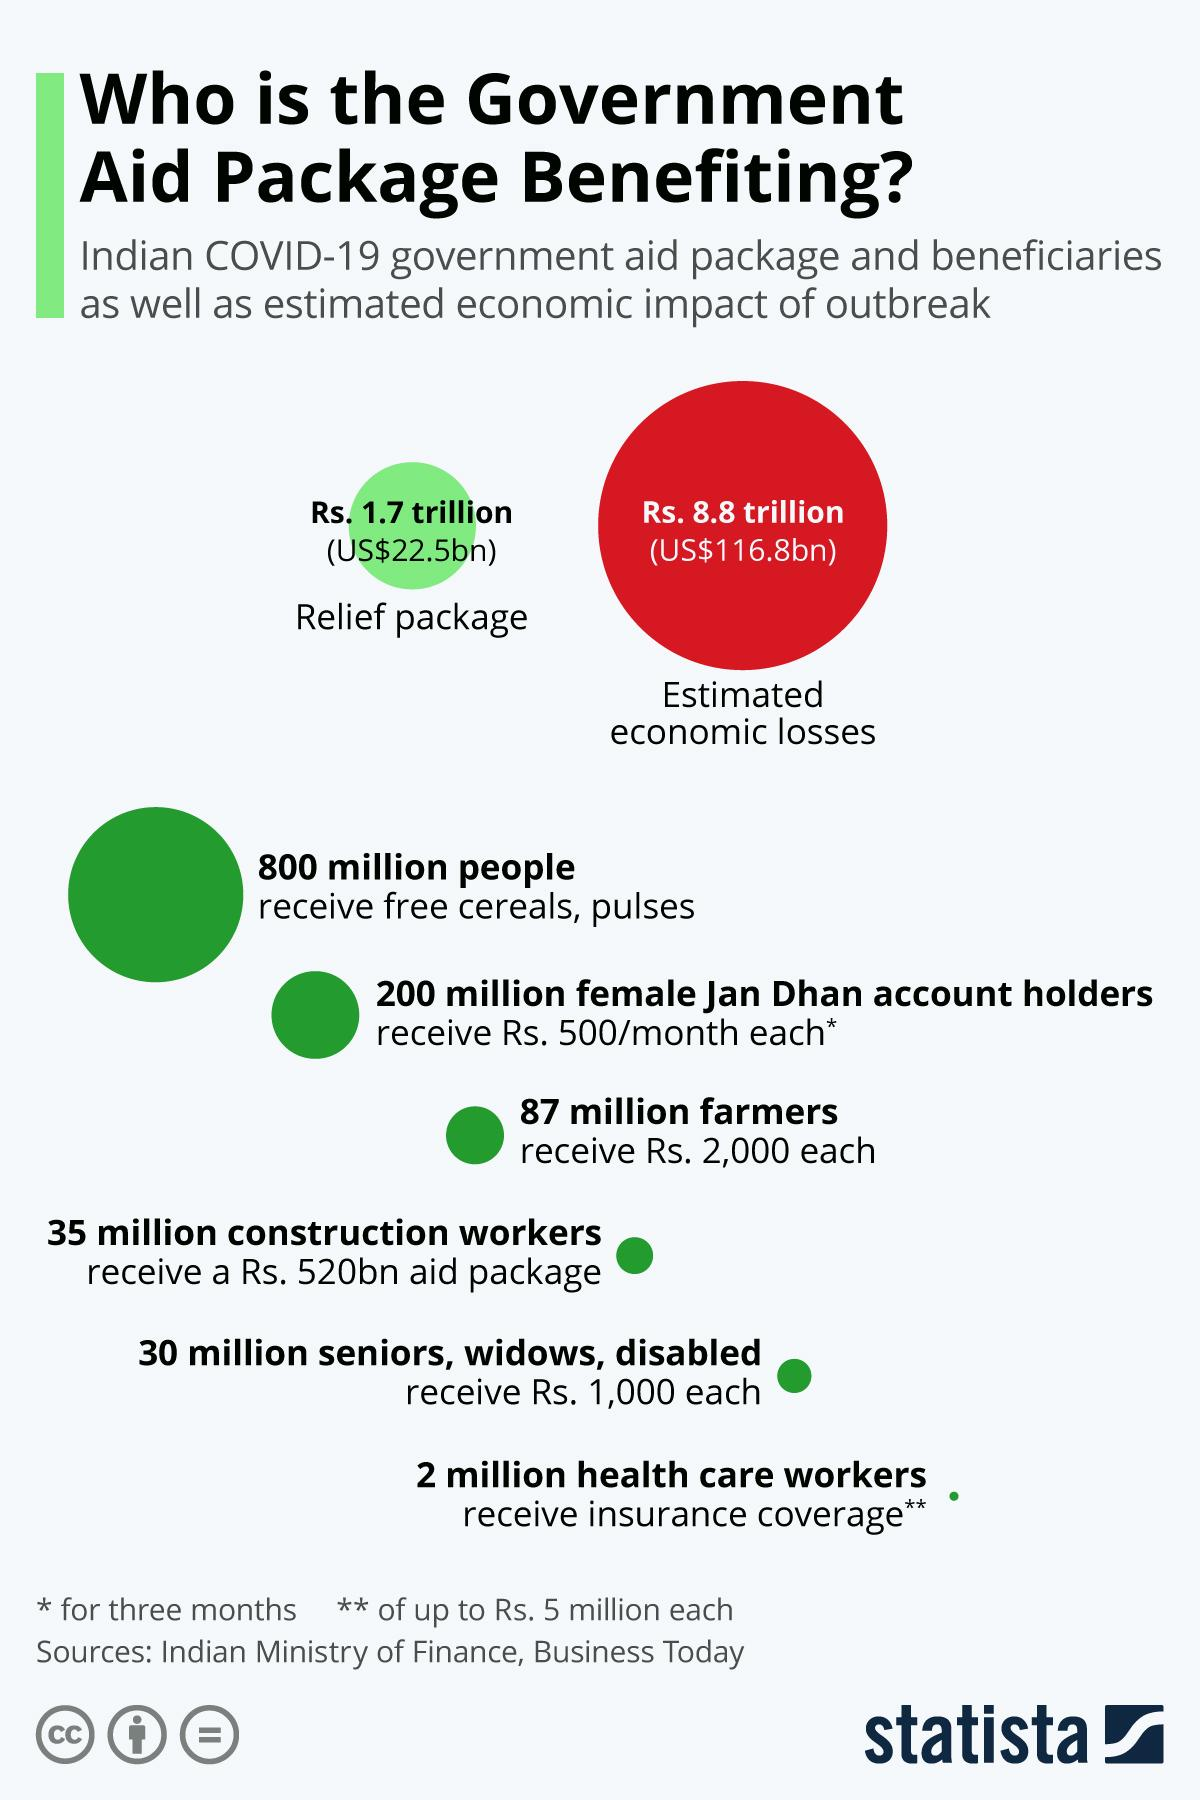Identify some key points in this picture. The recipients of 2000 rupees each are farmers. The estimated economic loss in rupees is approximately 8.8 trillion. It is estimated that 800 million people receive free cereals and pulses. 